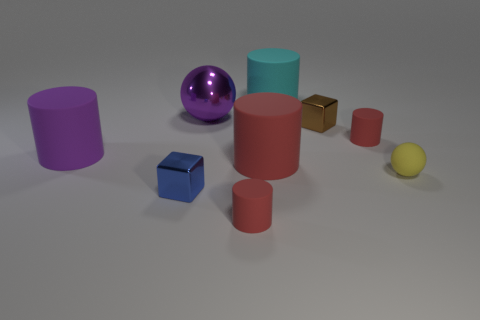There is a big thing that is both to the left of the large red object and to the right of the blue block; what material is it?
Keep it short and to the point. Metal. Does the shiny ball have the same color as the large matte cylinder to the left of the blue metal cube?
Your answer should be very brief. Yes. There is a sphere that is the same size as the brown metal cube; what is it made of?
Keep it short and to the point. Rubber. Is there a large purple cylinder made of the same material as the large cyan object?
Give a very brief answer. Yes. What number of big red rubber cylinders are there?
Keep it short and to the point. 1. Does the large red object have the same material as the cylinder in front of the tiny yellow object?
Ensure brevity in your answer.  Yes. There is a cylinder that is the same color as the large metallic thing; what material is it?
Give a very brief answer. Rubber. How many metallic things have the same color as the tiny matte ball?
Your answer should be very brief. 0. The yellow matte sphere has what size?
Provide a succinct answer. Small. There is a cyan matte thing; is its shape the same as the tiny brown shiny object right of the large cyan cylinder?
Your response must be concise. No. 